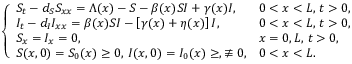<formula> <loc_0><loc_0><loc_500><loc_500>\left \{ \begin{array} { l l l l } { S _ { t } - d _ { S } S _ { x x } = \Lambda ( x ) - S - \beta ( x ) S I + \gamma ( x ) I , } & { 0 < x < L , \, t > 0 , } \\ { I _ { t } - d _ { I } I _ { x x } = \beta ( x ) S I - \left [ \gamma ( x ) + \eta ( x ) \right ] I , } & { 0 < x < L , \, t > 0 , } \\ { S _ { x } = I _ { x } = 0 , } & { x = 0 , L , \, t > 0 , } \\ { S ( x , 0 ) = S _ { 0 } ( x ) \geq 0 , \, I ( x , 0 ) = I _ { 0 } ( x ) \geq , \not \equiv 0 , } & { 0 < x < L . } \end{array}</formula> 